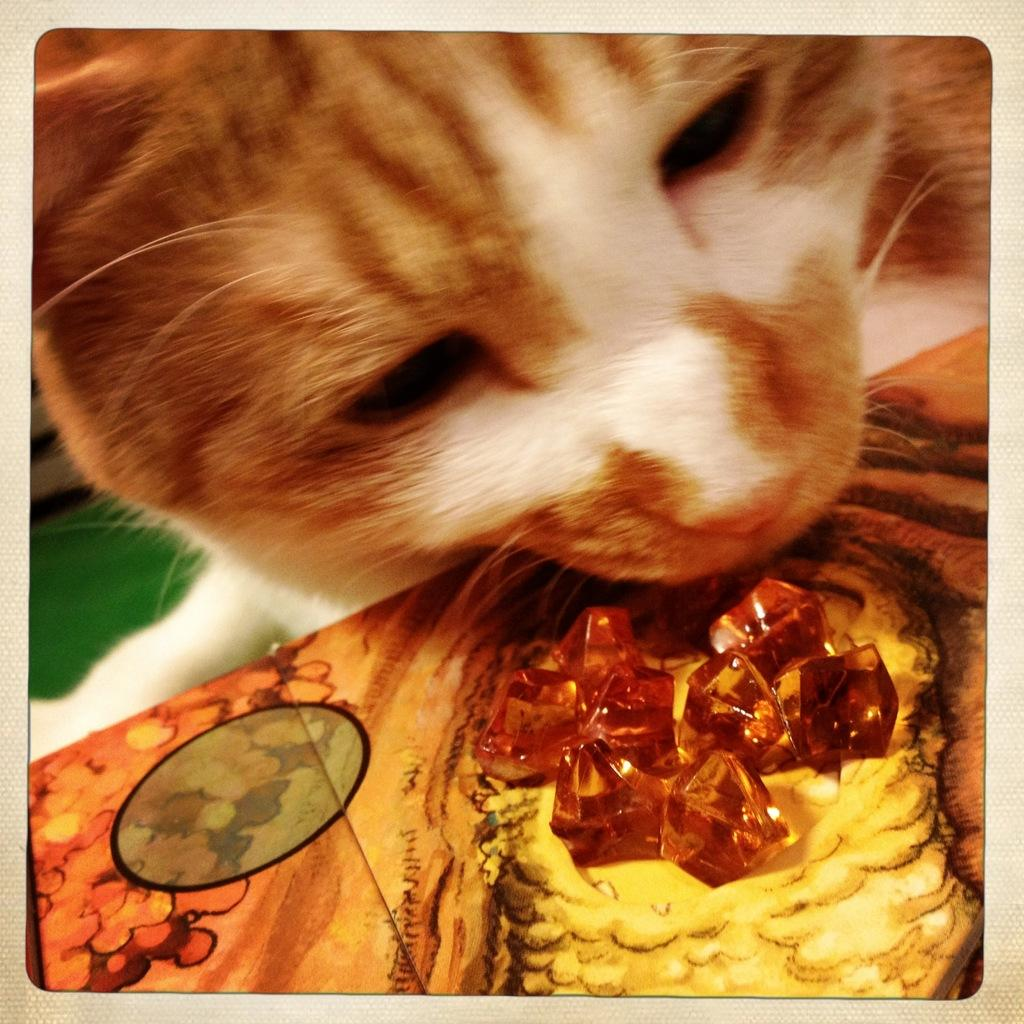What has been done to the image? The image has been edited. What type of animal can be seen in the image? There is a cat in the image. What is placed in front of the cat? There are crystals on an object in front of the cat. Can you see the seashore in the background of the image? There is no seashore visible in the image. What is the height of the vase in the image? There is no vase present in the image. 